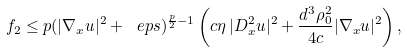<formula> <loc_0><loc_0><loc_500><loc_500>f _ { 2 } \leq p ( | \nabla _ { x } u | ^ { 2 } + \ e p s ) ^ { \frac { p } { 2 } - 1 } \left ( c \eta \, | D _ { x } ^ { 2 } u | ^ { 2 } + \frac { d ^ { 3 } \rho ^ { 2 } _ { 0 } } { 4 c } | \nabla _ { x } u | ^ { 2 } \right ) ,</formula> 